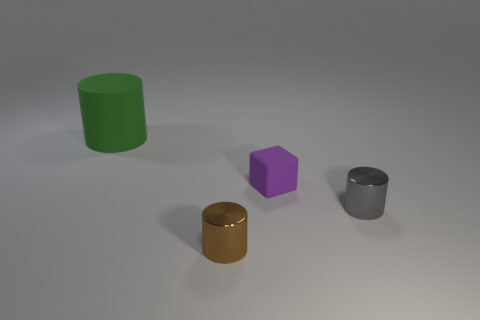Are the objects on the image intended for a specific function or purpose? Based on the image, it's not clear if the objects serve a functional purpose. They appear to be simple geometric shapes, possibly used for a display or an educational purpose to demonstrate shapes and colors. 